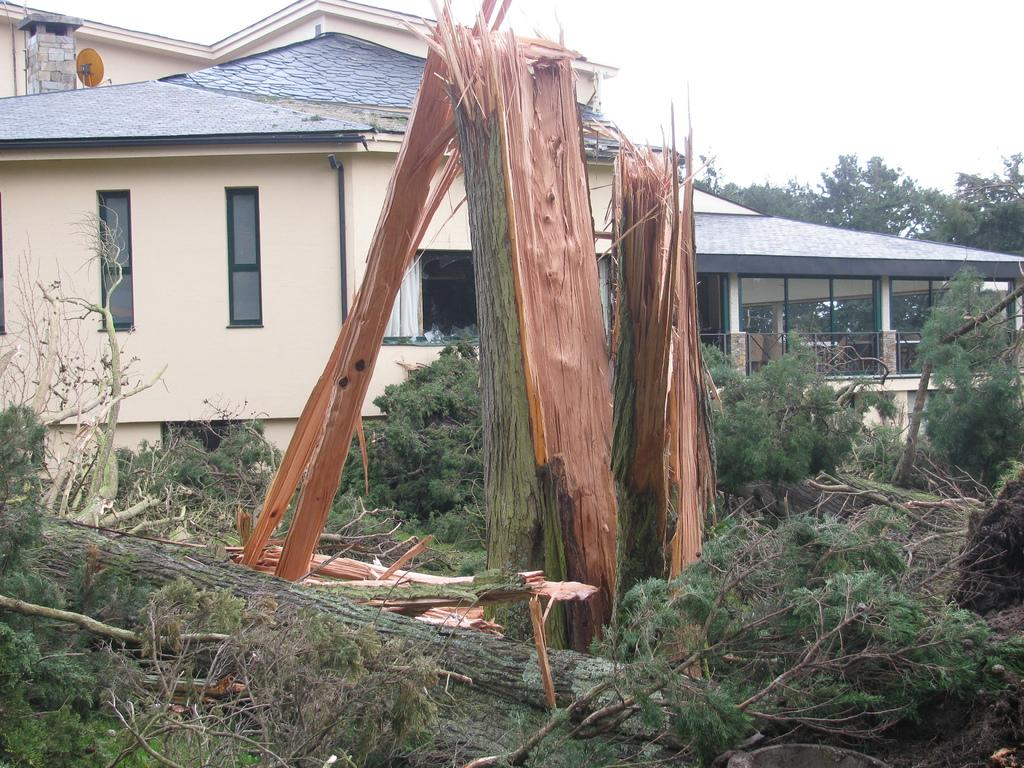What type of vegetation can be seen in the image? There are broken trees and plants in the image. What can be seen in the background of the image? There are buildings, more trees, and the sky visible in the background of the image. What type of mist can be seen surrounding the trees in the image? There is no mist present in the image; it only features broken trees, plants, buildings, and the sky in the background. 